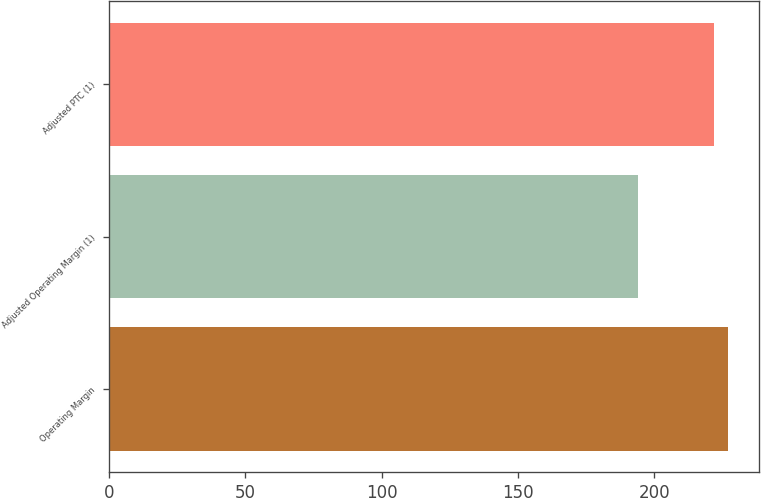<chart> <loc_0><loc_0><loc_500><loc_500><bar_chart><fcel>Operating Margin<fcel>Adjusted Operating Margin (1)<fcel>Adjusted PTC (1)<nl><fcel>227<fcel>194<fcel>222<nl></chart> 